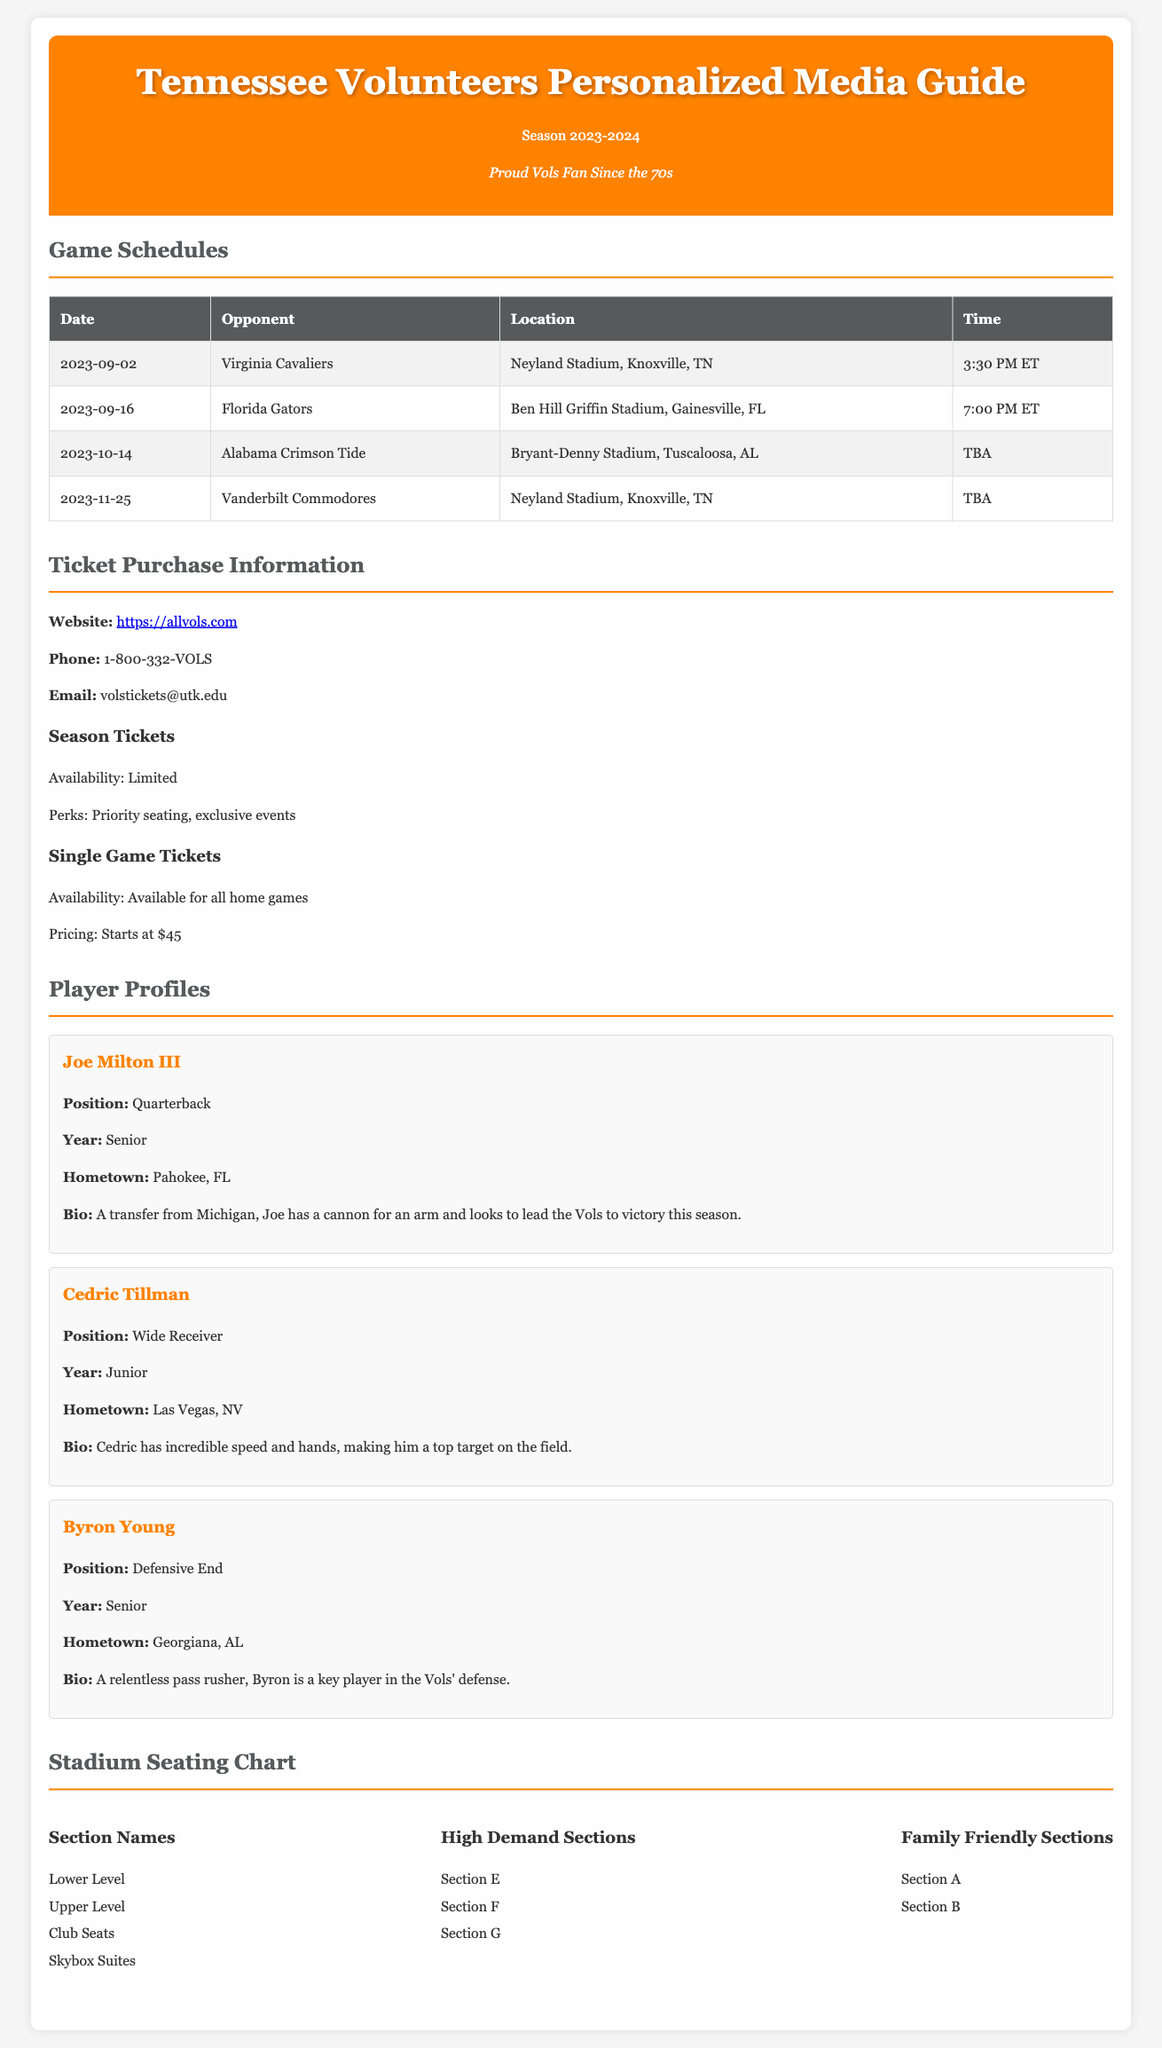What is the date of the first game? The first game is scheduled for September 2, 2023, against Virginia Cavaliers.
Answer: September 2, 2023 Who is the quarterback for the Tennessee Volunteers? The document lists Joe Milton III as the quarterback for the team.
Answer: Joe Milton III What is the website for ticket purchases? The document provides the website for purchasing tickets as https://allvols.com.
Answer: https://allvols.com Which section is considered family-friendly? The document identifies Section A and Section B as family-friendly sections.
Answer: Section A and Section B What time is the game against the Florida Gators? The game against the Florida Gators is at 7:00 PM ET, according to the schedule.
Answer: 7:00 PM ET How many players are profiled in the document? The document features profiles for three players: Joe Milton III, Cedric Tillman, and Byron Young.
Answer: Three What is the price starting point for single game tickets? The document states that single game ticket pricing starts at $45.
Answer: $45 Which opponent is scheduled for November 25, 2023? The schedule lists the Vanderbilt Commodores as the opponent on that date.
Answer: Vanderbilt Commodores What is one perk of purchasing season tickets? The document mentions priority seating as one of the perks for season ticket holders.
Answer: Priority seating 